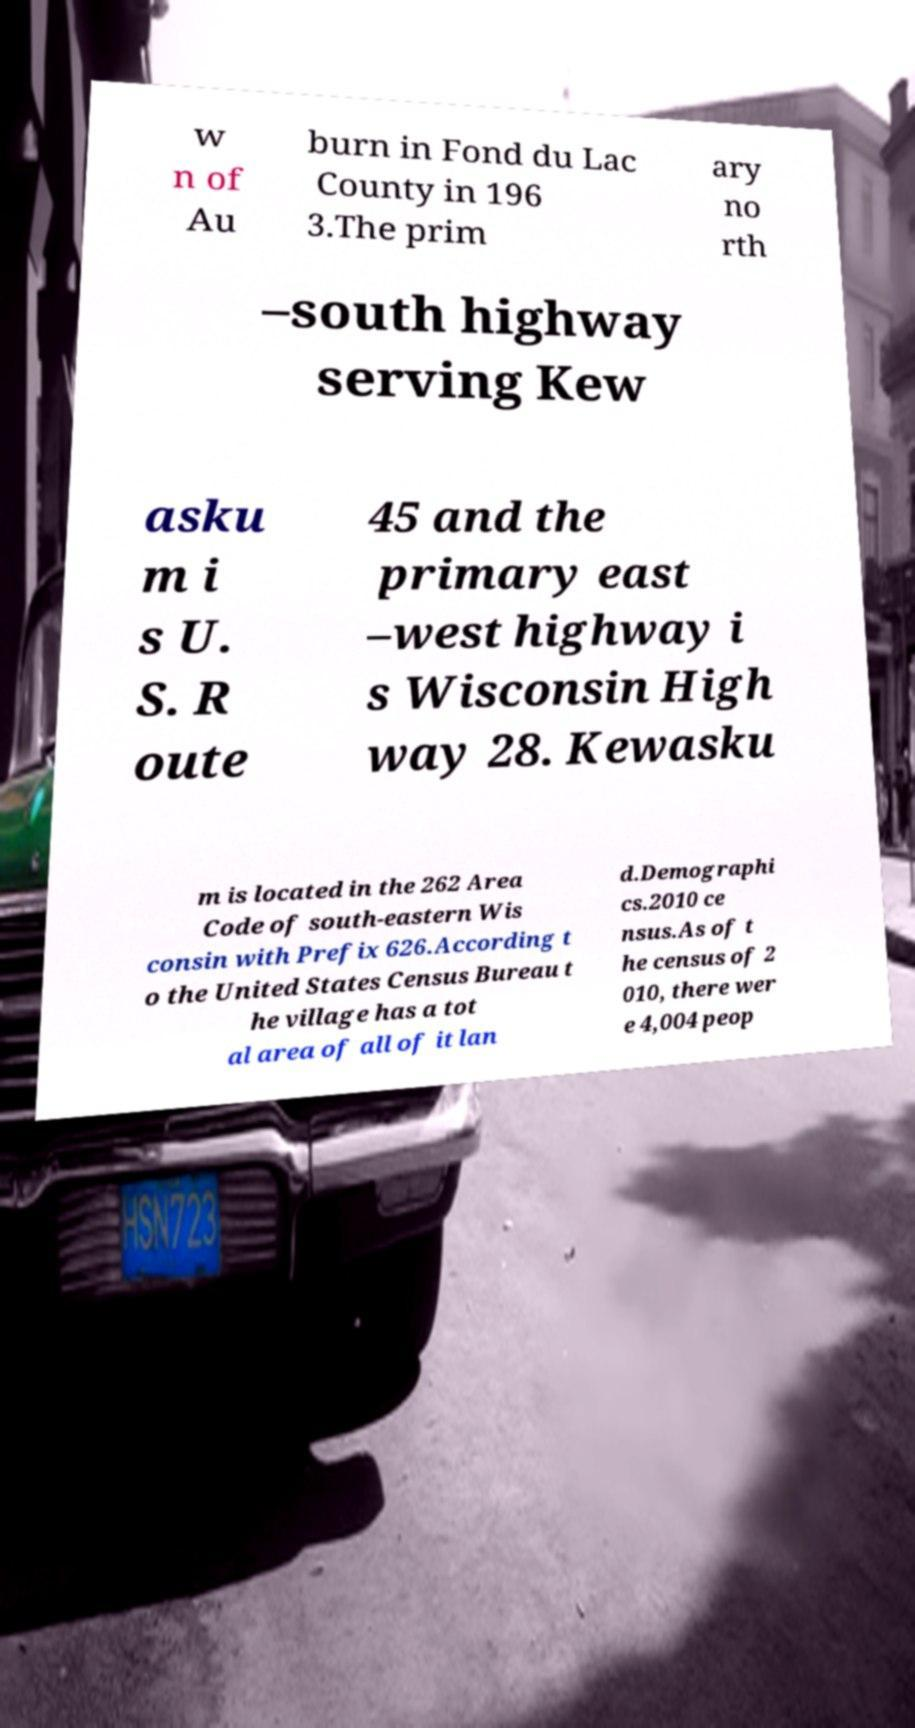Could you assist in decoding the text presented in this image and type it out clearly? w n of Au burn in Fond du Lac County in 196 3.The prim ary no rth –south highway serving Kew asku m i s U. S. R oute 45 and the primary east –west highway i s Wisconsin High way 28. Kewasku m is located in the 262 Area Code of south-eastern Wis consin with Prefix 626.According t o the United States Census Bureau t he village has a tot al area of all of it lan d.Demographi cs.2010 ce nsus.As of t he census of 2 010, there wer e 4,004 peop 